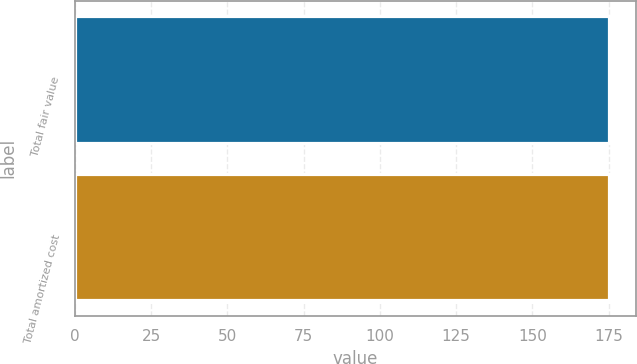<chart> <loc_0><loc_0><loc_500><loc_500><bar_chart><fcel>Total fair value<fcel>Total amortized cost<nl><fcel>175<fcel>175.1<nl></chart> 